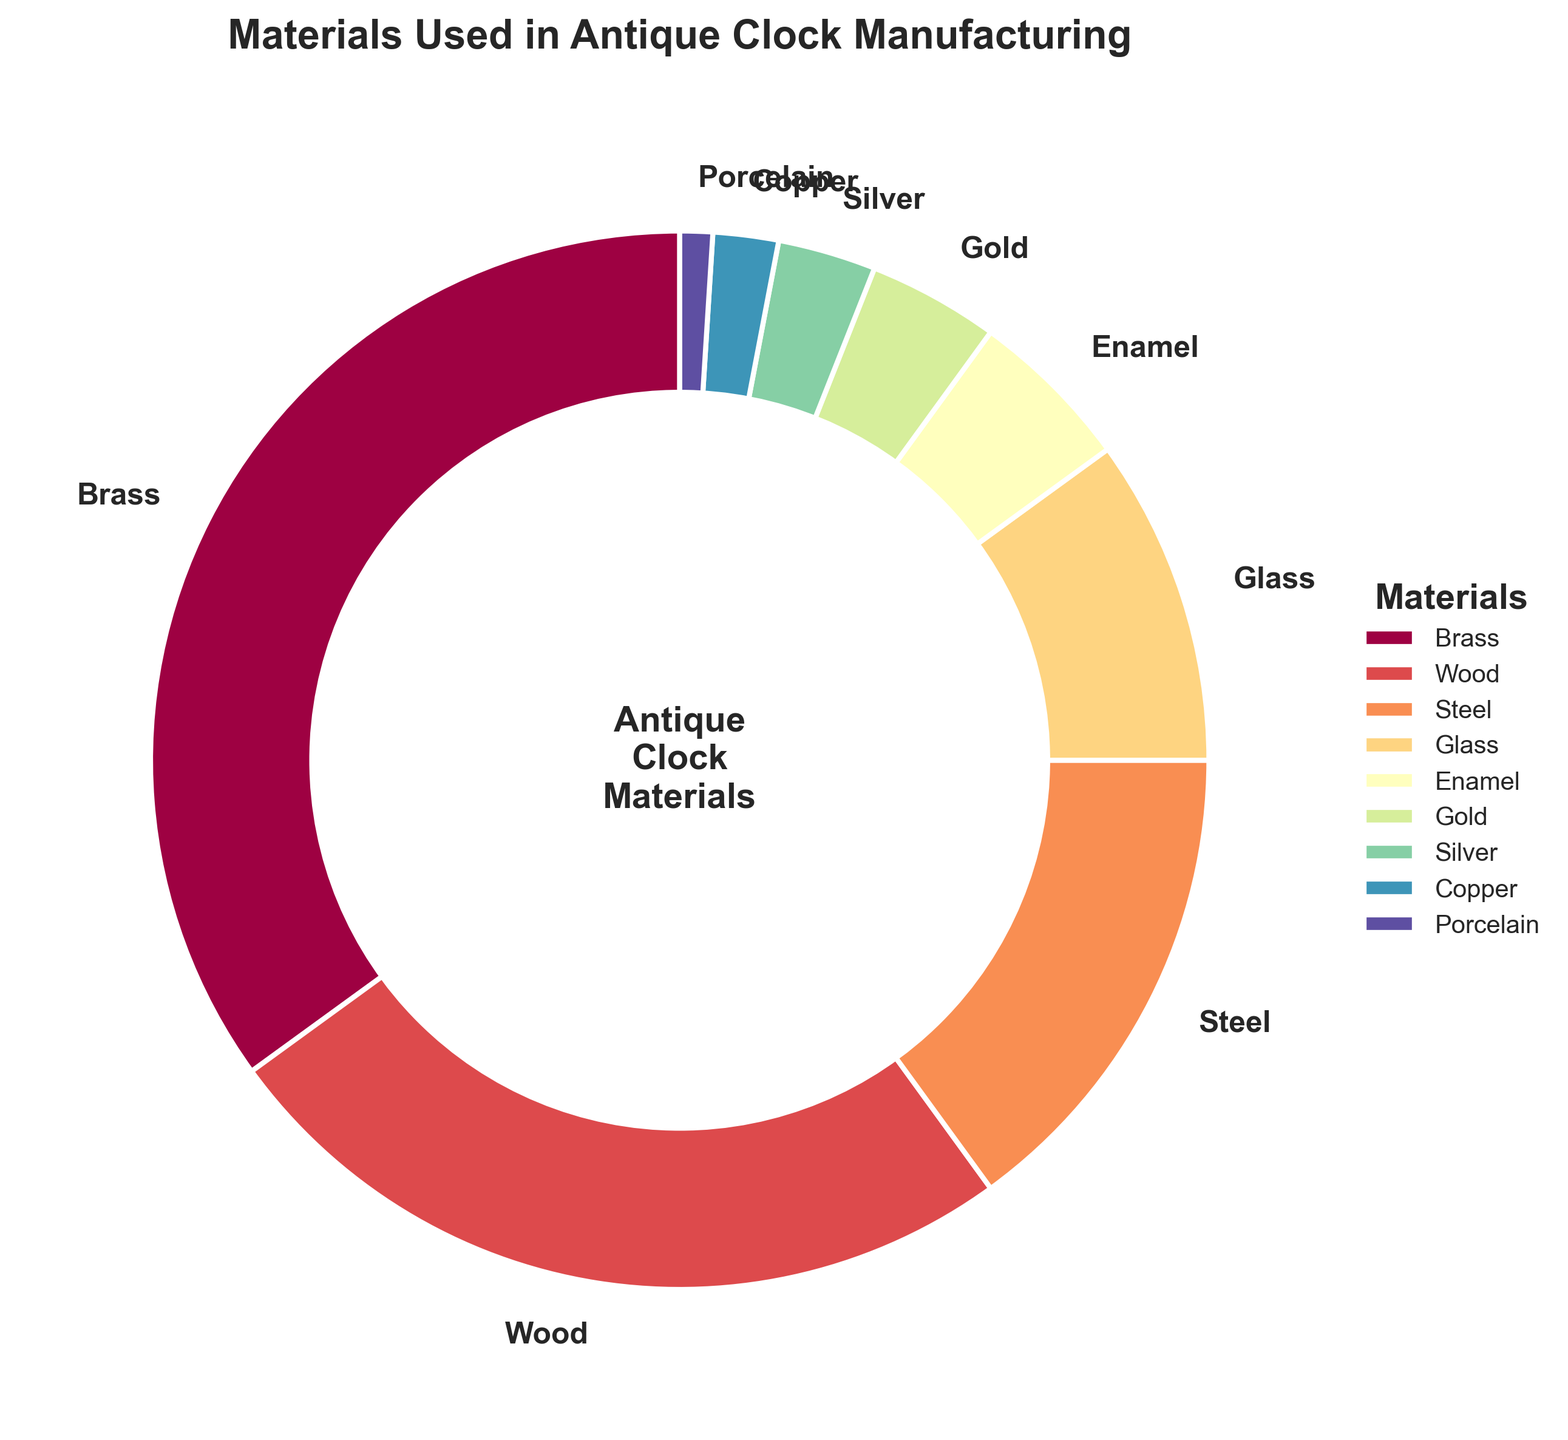What is the most used material in antique clock manufacturing? The pie chart shows that Brass makes up the largest portion with a percentage of 35%.
Answer: Brass Which two materials contribute equally to the total percentage? Both Gold and Enamel contribute 4% and 5% respectively, but there is no exact match for percentage. However, if we consider close values, they are indeed close to each other.
Answer: There are no exact matches What is the combined percentage of materials whose individual contribution is less than 10%? The materials below 10% are Glass (10%), Enamel (5%), Gold (4%), Silver (3%), Copper (2%), and Porcelain (1%). Their combined percentage is 10% + 5% + 4% + 3% + 2% + 1% = 25%.
Answer: 25% Which material shares the smallest percentage in the manufacturing process? Based on the pie chart, Porcelain shares the smallest percentage with only 1%.
Answer: Porcelain How much higher is the percentage of Brass compared to Wood? The percentage for Brass is 35% whereas for Wood it is 25%. The difference is 35% - 25% = 10%.
Answer: 10% What materials together account for two-thirds (around 66.6%) of the total percentage? The total percentage is 30% + 25% + 15% + 10% + 5% = 85%. Checking the largest contributions: Brass (35%), Wood (25%), and Steel (15%) together make up 35% + 25% + 15% = 75%, which is more than two-thirds.
Answer: Brass, Wood, Steel Which material has a percentage only one unit less than Steel? Steel has a percentage of 15%, Glass has a percentage of 10%, Enamel has a percentage of 5%, Gold has a percentage of 4%. Enamel is the closest with a value of 5%, which is 10 units less.
Answer: None immediate one less What is the third most used material in antique clock manufacturing? Referring to the pie chart, the material usage in descending order is Brass (35%), Wood (25%), Steel (15%), making Steel the third most used material.
Answer: Steel If you combine Gold, Silver, and Copper, what is their total contribution? The contribution percentages for Gold, Silver, and Copper are 4%, 3%, and 2%. Adding them together gives 4% + 3% + 2% = 9%.
Answer: 9% What is the percentage difference between the usage of Steel and Enamel? Steel accounts for 15% while Enamel accounts for 5%. The difference between them is 15% - 5% = 10%.
Answer: 10% 